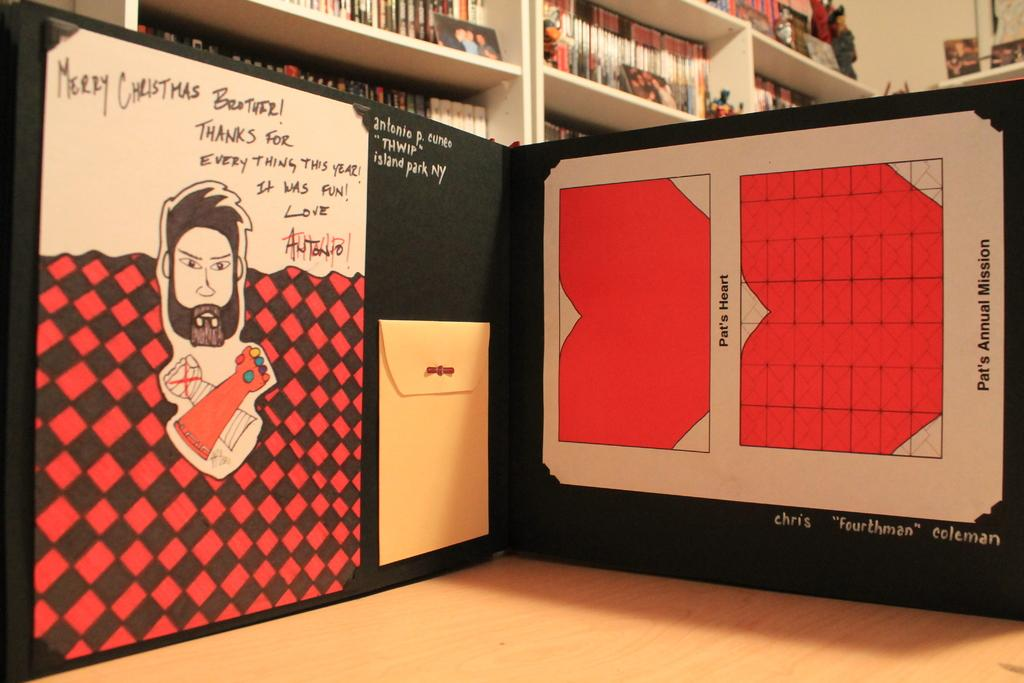<image>
Summarize the visual content of the image. Board with a christmas picture in it and a small note 